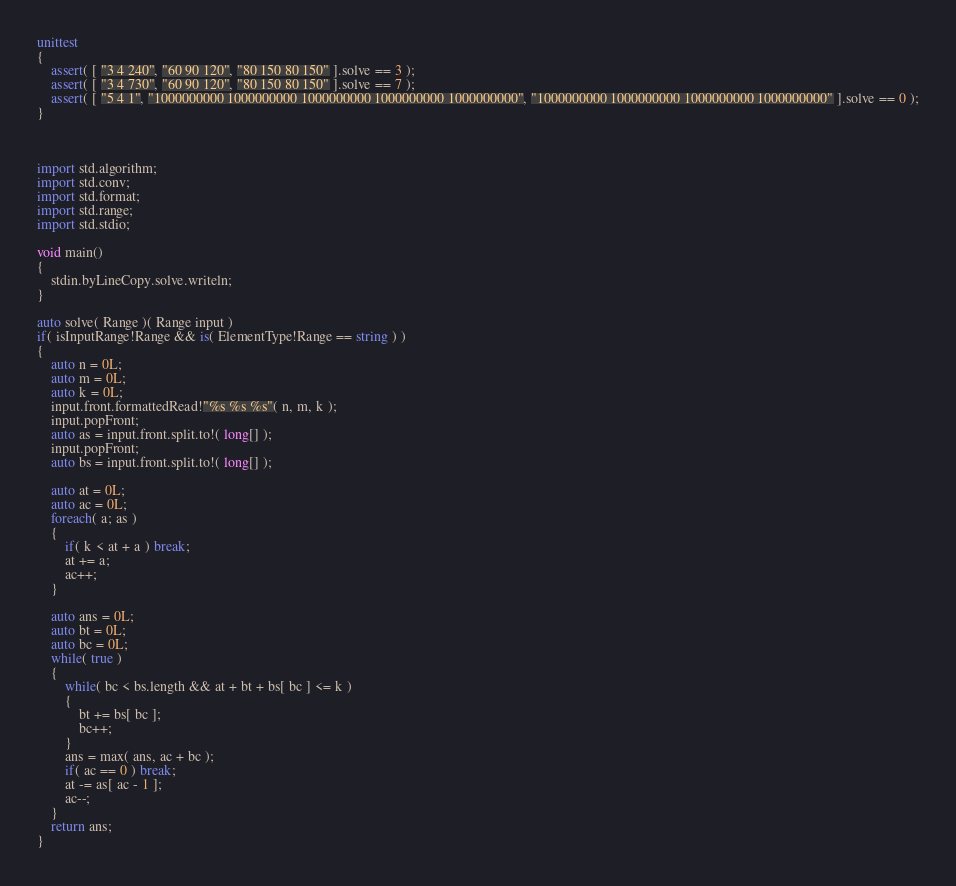<code> <loc_0><loc_0><loc_500><loc_500><_D_>unittest
{
	assert( [ "3 4 240", "60 90 120", "80 150 80 150" ].solve == 3 );
	assert( [ "3 4 730", "60 90 120", "80 150 80 150" ].solve == 7 );
	assert( [ "5 4 1", "1000000000 1000000000 1000000000 1000000000 1000000000", "1000000000 1000000000 1000000000 1000000000" ].solve == 0 );
}



import std.algorithm;
import std.conv;
import std.format;
import std.range;
import std.stdio;

void main()
{
	stdin.byLineCopy.solve.writeln;
}

auto solve( Range )( Range input )
if( isInputRange!Range && is( ElementType!Range == string ) )
{
	auto n = 0L;
	auto m = 0L;
	auto k = 0L;
	input.front.formattedRead!"%s %s %s"( n, m, k );
	input.popFront;
	auto as = input.front.split.to!( long[] );
	input.popFront;
	auto bs = input.front.split.to!( long[] );
	
	auto at = 0L;
	auto ac = 0L;
	foreach( a; as )
	{
		if( k < at + a ) break;
		at += a;
		ac++;
	}
	
	auto ans = 0L;
	auto bt = 0L;
	auto bc = 0L;
	while( true )
	{
		while( bc < bs.length && at + bt + bs[ bc ] <= k )
		{
			bt += bs[ bc ];
			bc++;
		}
		ans = max( ans, ac + bc );
		if( ac == 0 ) break;
		at -= as[ ac - 1 ];
		ac--;
	}
	return ans;
}
</code> 